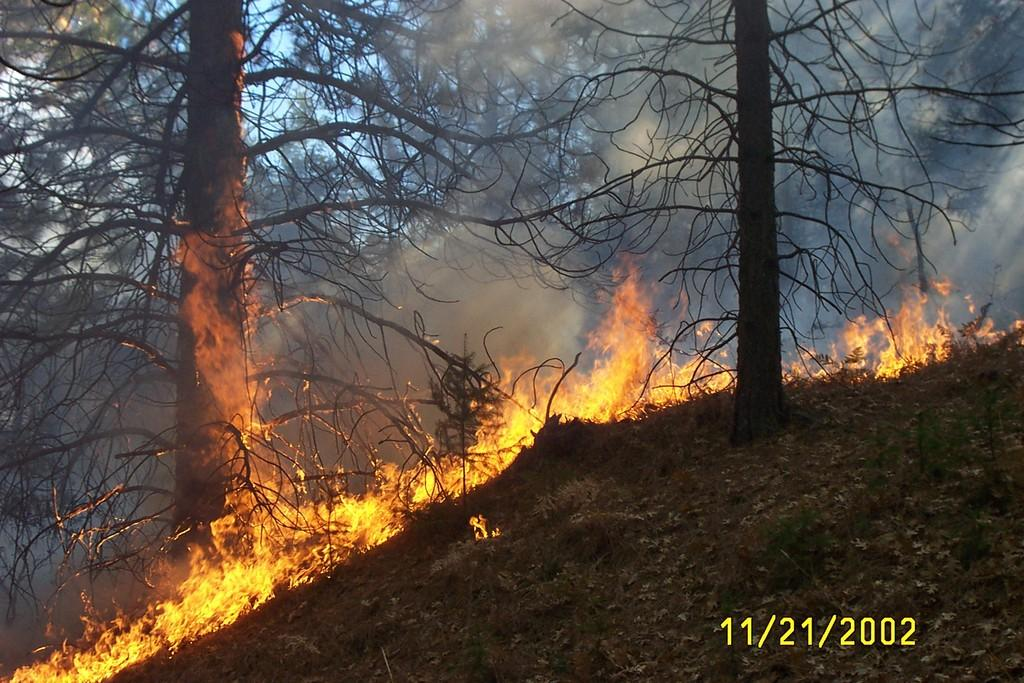What type of vegetation can be seen in the image? There are trees in the image. What is happening in the image? There is a fire in the image. What is the surface on which the fire is burning? The ground is visible in the image. Who is the representative of the trees in the image? There is no representative present in the image; it simply shows trees and a fire. Can you tell me how many friends are standing near the trees in the image? There is no mention of friends or people in the image; it only features trees and a fire. 